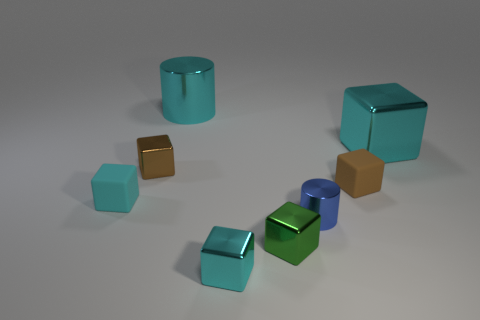What material are the cubes closest to the camera made of, and how do you think this might affect their weight? The cubes closest to the camera appear to have a metallic sheen, suggesting that they are made of metal. This would likely make them heavier compared to cubes made of lighter materials like rubber or plastic. 